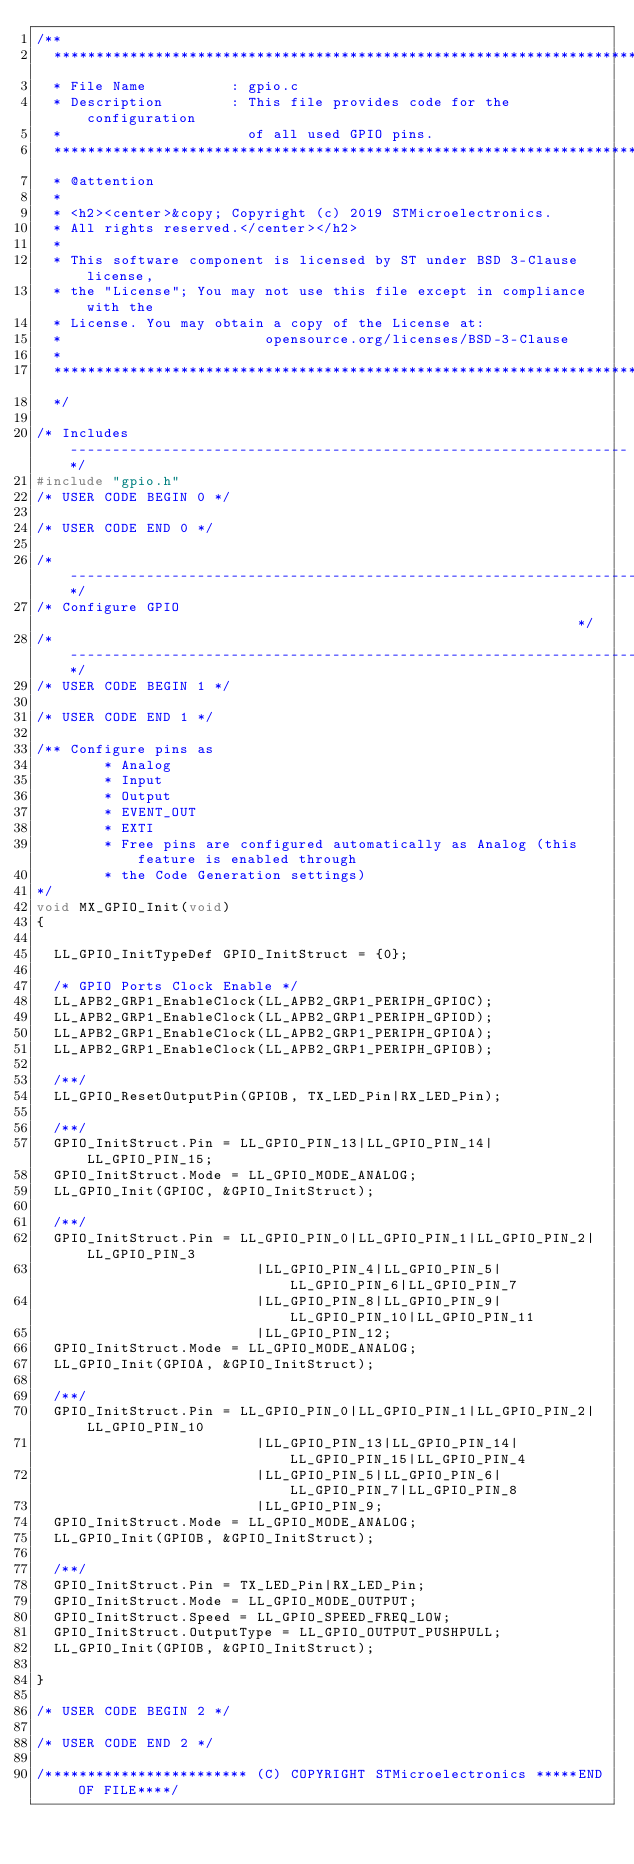<code> <loc_0><loc_0><loc_500><loc_500><_C_>/**
  ******************************************************************************
  * File Name          : gpio.c
  * Description        : This file provides code for the configuration
  *                      of all used GPIO pins.
  ******************************************************************************
  * @attention
  *
  * <h2><center>&copy; Copyright (c) 2019 STMicroelectronics.
  * All rights reserved.</center></h2>
  *
  * This software component is licensed by ST under BSD 3-Clause license,
  * the "License"; You may not use this file except in compliance with the
  * License. You may obtain a copy of the License at:
  *                        opensource.org/licenses/BSD-3-Clause
  *
  ******************************************************************************
  */

/* Includes ------------------------------------------------------------------*/
#include "gpio.h"
/* USER CODE BEGIN 0 */

/* USER CODE END 0 */

/*----------------------------------------------------------------------------*/
/* Configure GPIO                                                             */
/*----------------------------------------------------------------------------*/
/* USER CODE BEGIN 1 */

/* USER CODE END 1 */

/** Configure pins as 
        * Analog 
        * Input 
        * Output
        * EVENT_OUT
        * EXTI
        * Free pins are configured automatically as Analog (this feature is enabled through 
        * the Code Generation settings)
*/
void MX_GPIO_Init(void)
{

  LL_GPIO_InitTypeDef GPIO_InitStruct = {0};

  /* GPIO Ports Clock Enable */
  LL_APB2_GRP1_EnableClock(LL_APB2_GRP1_PERIPH_GPIOC);
  LL_APB2_GRP1_EnableClock(LL_APB2_GRP1_PERIPH_GPIOD);
  LL_APB2_GRP1_EnableClock(LL_APB2_GRP1_PERIPH_GPIOA);
  LL_APB2_GRP1_EnableClock(LL_APB2_GRP1_PERIPH_GPIOB);

  /**/
  LL_GPIO_ResetOutputPin(GPIOB, TX_LED_Pin|RX_LED_Pin);

  /**/
  GPIO_InitStruct.Pin = LL_GPIO_PIN_13|LL_GPIO_PIN_14|LL_GPIO_PIN_15;
  GPIO_InitStruct.Mode = LL_GPIO_MODE_ANALOG;
  LL_GPIO_Init(GPIOC, &GPIO_InitStruct);

  /**/
  GPIO_InitStruct.Pin = LL_GPIO_PIN_0|LL_GPIO_PIN_1|LL_GPIO_PIN_2|LL_GPIO_PIN_3 
                          |LL_GPIO_PIN_4|LL_GPIO_PIN_5|LL_GPIO_PIN_6|LL_GPIO_PIN_7 
                          |LL_GPIO_PIN_8|LL_GPIO_PIN_9|LL_GPIO_PIN_10|LL_GPIO_PIN_11 
                          |LL_GPIO_PIN_12;
  GPIO_InitStruct.Mode = LL_GPIO_MODE_ANALOG;
  LL_GPIO_Init(GPIOA, &GPIO_InitStruct);

  /**/
  GPIO_InitStruct.Pin = LL_GPIO_PIN_0|LL_GPIO_PIN_1|LL_GPIO_PIN_2|LL_GPIO_PIN_10 
                          |LL_GPIO_PIN_13|LL_GPIO_PIN_14|LL_GPIO_PIN_15|LL_GPIO_PIN_4 
                          |LL_GPIO_PIN_5|LL_GPIO_PIN_6|LL_GPIO_PIN_7|LL_GPIO_PIN_8 
                          |LL_GPIO_PIN_9;
  GPIO_InitStruct.Mode = LL_GPIO_MODE_ANALOG;
  LL_GPIO_Init(GPIOB, &GPIO_InitStruct);

  /**/
  GPIO_InitStruct.Pin = TX_LED_Pin|RX_LED_Pin;
  GPIO_InitStruct.Mode = LL_GPIO_MODE_OUTPUT;
  GPIO_InitStruct.Speed = LL_GPIO_SPEED_FREQ_LOW;
  GPIO_InitStruct.OutputType = LL_GPIO_OUTPUT_PUSHPULL;
  LL_GPIO_Init(GPIOB, &GPIO_InitStruct);

}

/* USER CODE BEGIN 2 */

/* USER CODE END 2 */

/************************ (C) COPYRIGHT STMicroelectronics *****END OF FILE****/
</code> 